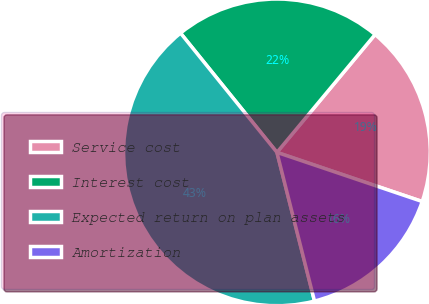<chart> <loc_0><loc_0><loc_500><loc_500><pie_chart><fcel>Service cost<fcel>Interest cost<fcel>Expected return on plan assets<fcel>Amortization<nl><fcel>19.14%<fcel>21.87%<fcel>43.12%<fcel>15.87%<nl></chart> 